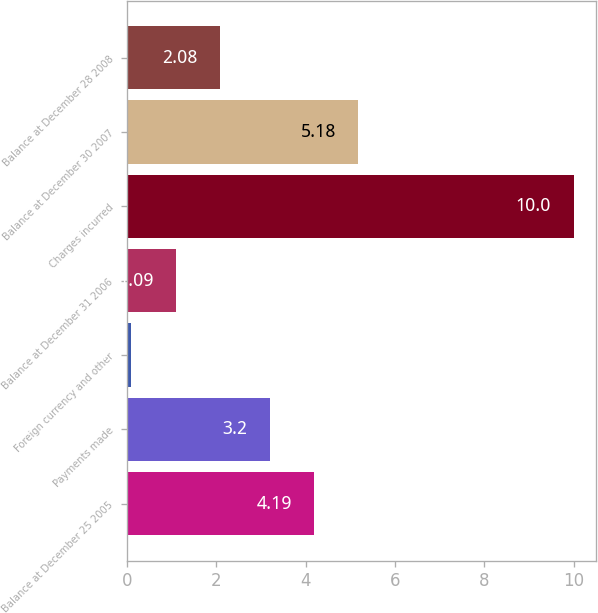Convert chart. <chart><loc_0><loc_0><loc_500><loc_500><bar_chart><fcel>Balance at December 25 2005<fcel>Payments made<fcel>Foreign currency and other<fcel>Balance at December 31 2006<fcel>Charges incurred<fcel>Balance at December 30 2007<fcel>Balance at December 28 2008<nl><fcel>4.19<fcel>3.2<fcel>0.1<fcel>1.09<fcel>10<fcel>5.18<fcel>2.08<nl></chart> 